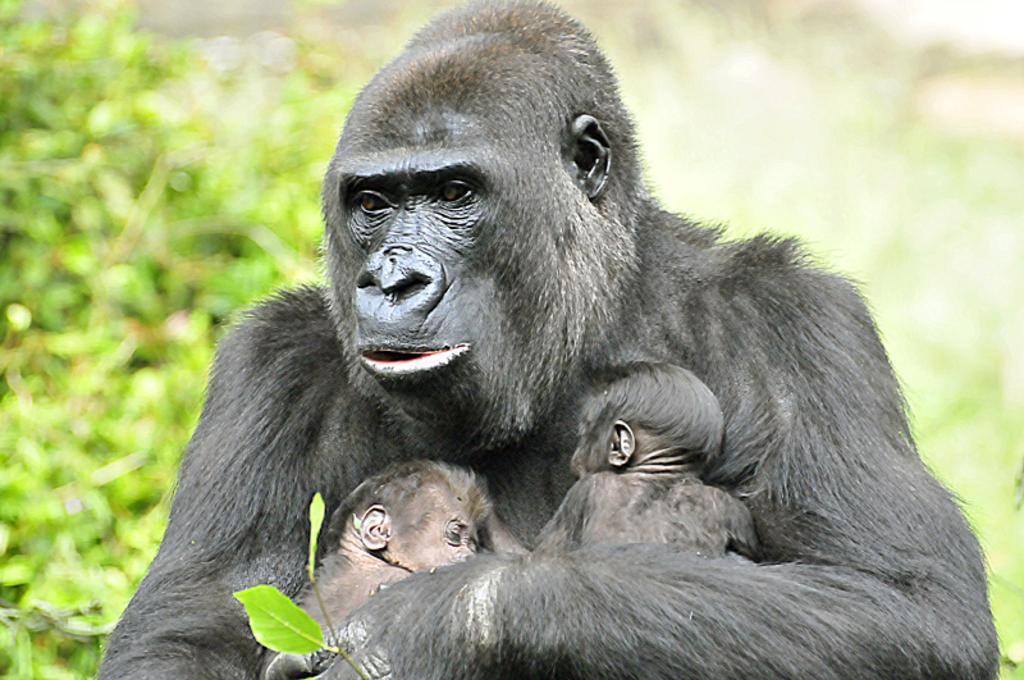In one or two sentences, can you explain what this image depicts? This picture contains a chimpanzee and it is holding its babies with its hands. There are trees in the background and it is blurred. This picture might be clicked in a zoo. 